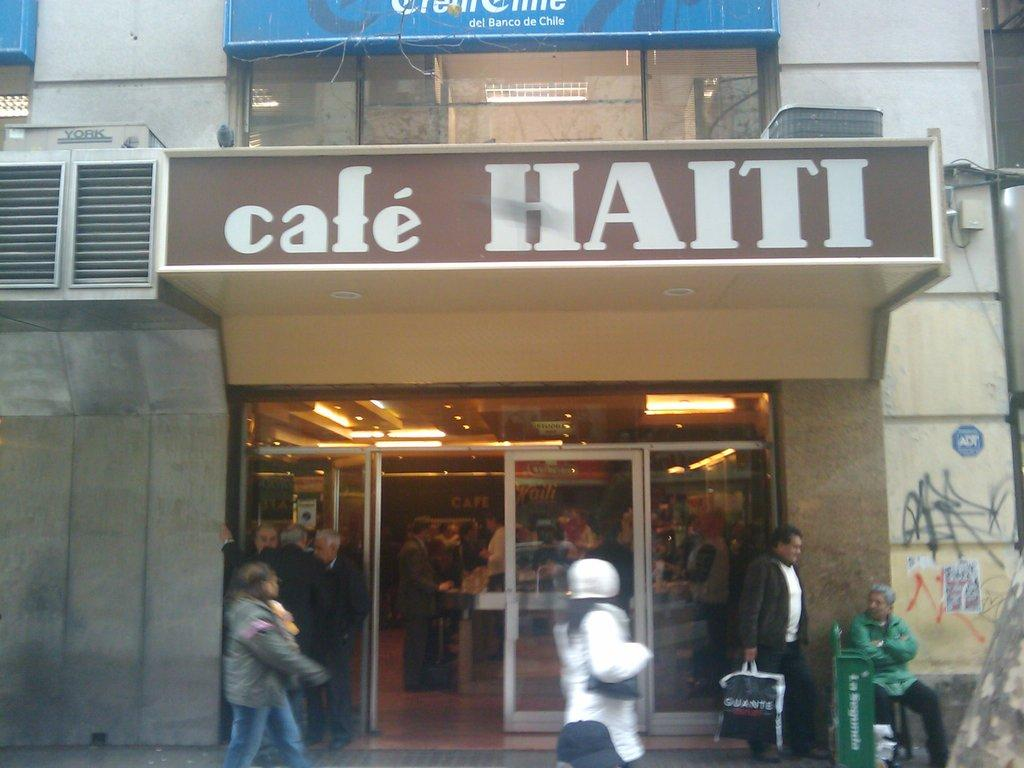What type of structure is present in the image? There is a building in the image. What can be seen attached to the building? There are boards in the image. What illuminates the area in the image? There are lights in the image. What objects are present for people to use? There are glasses in the image. Are there any people visible in the image? Yes, there are people in the image. What is available for disposing of waste in the image? There is a bin in the image. What type of signage is present in the image? There are posters in the image. Can you describe any other objects present in the image? There are other objects in the image, but their specific details are not mentioned in the provided facts. What type of goose is present in the image? There is no goose present in the image. What type of legal advice can be obtained from the lawyer in the image? There is no lawyer present in the image. 